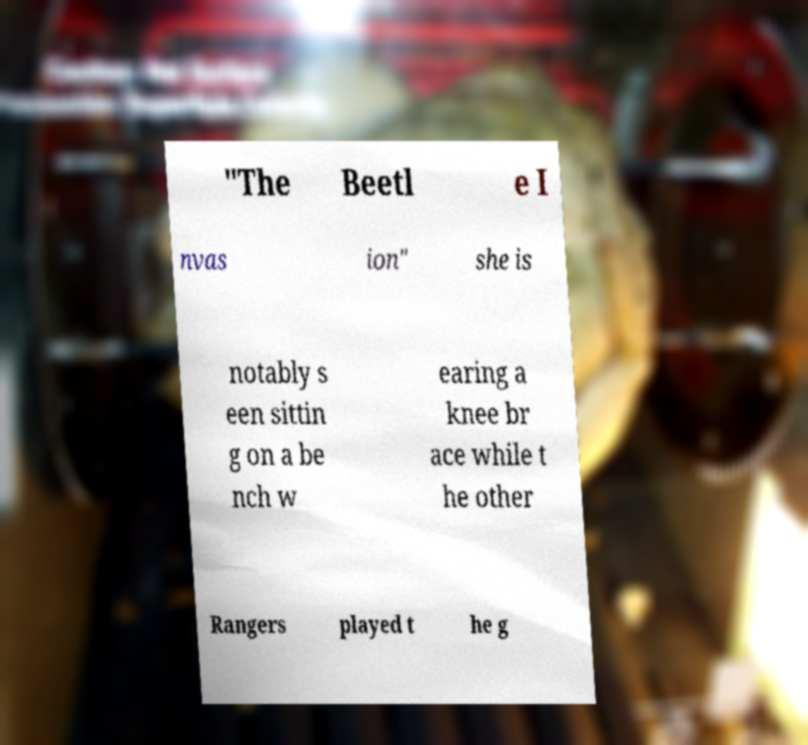For documentation purposes, I need the text within this image transcribed. Could you provide that? "The Beetl e I nvas ion" she is notably s een sittin g on a be nch w earing a knee br ace while t he other Rangers played t he g 